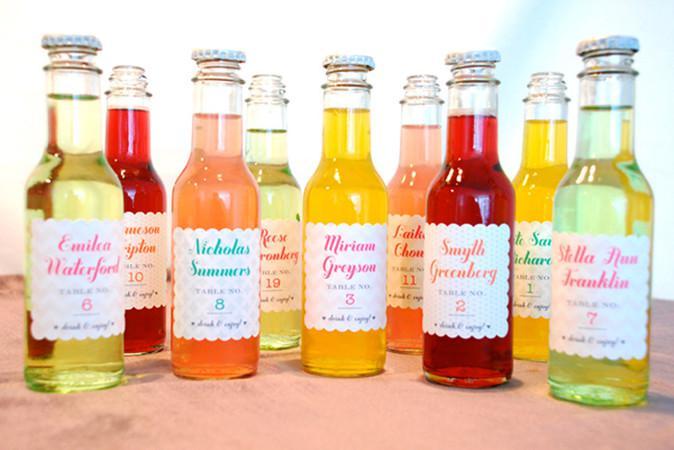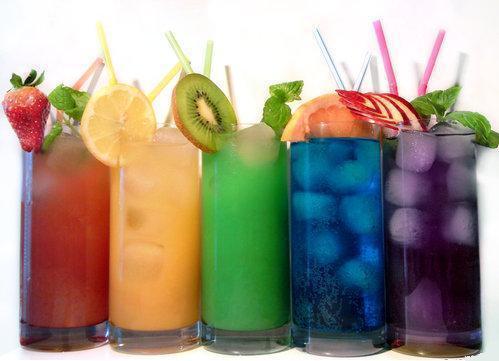The first image is the image on the left, the second image is the image on the right. Evaluate the accuracy of this statement regarding the images: "There are four uncapped bottles in the left image.". Is it true? Answer yes or no. Yes. 